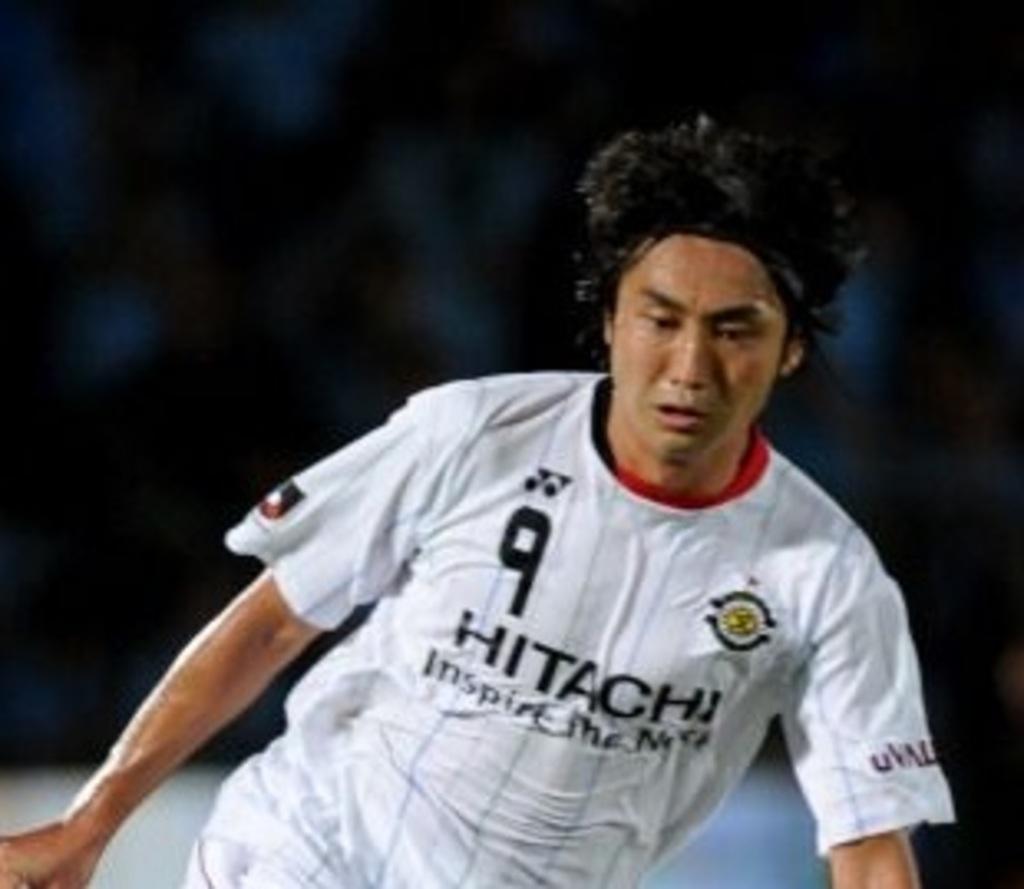What electronics brand is on the athlete's jersey?
Your answer should be compact. Hitachi. What is the jersey number of the player?
Your answer should be very brief. 9. 